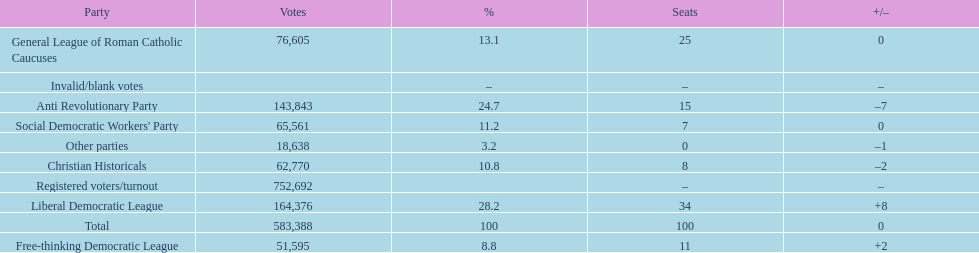Name the top three parties? Liberal Democratic League, Anti Revolutionary Party, General League of Roman Catholic Caucuses. 